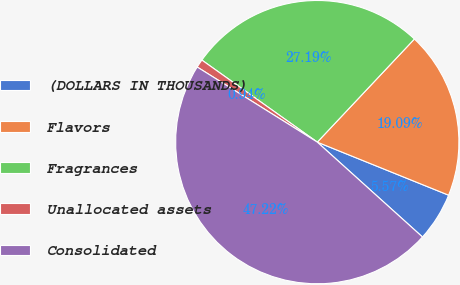Convert chart to OTSL. <chart><loc_0><loc_0><loc_500><loc_500><pie_chart><fcel>(DOLLARS IN THOUSANDS)<fcel>Flavors<fcel>Fragrances<fcel>Unallocated assets<fcel>Consolidated<nl><fcel>5.57%<fcel>19.09%<fcel>27.19%<fcel>0.94%<fcel>47.22%<nl></chart> 